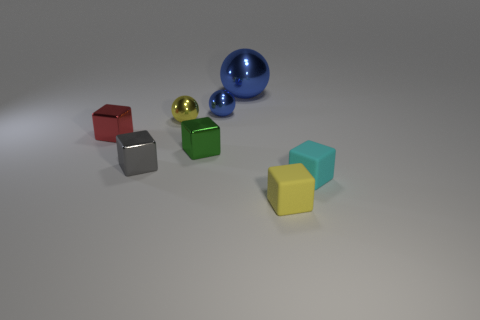What size is the metal cube right of the yellow object behind the tiny red metallic thing?
Offer a terse response. Small. What is the color of the other large thing that is the same shape as the yellow metal object?
Provide a short and direct response. Blue. How many rubber things are the same color as the big ball?
Your answer should be very brief. 0. What is the size of the green metallic object?
Ensure brevity in your answer.  Small. Does the cyan object have the same size as the red metallic cube?
Make the answer very short. Yes. There is a block that is both to the right of the yellow ball and behind the tiny cyan matte block; what is its color?
Make the answer very short. Green. How many large red balls have the same material as the gray object?
Your answer should be compact. 0. What number of red metallic things are there?
Make the answer very short. 1. There is a green metal thing; is it the same size as the object that is right of the yellow matte cube?
Provide a succinct answer. Yes. What is the yellow thing behind the tiny metal cube on the right side of the gray metal cube made of?
Make the answer very short. Metal. 